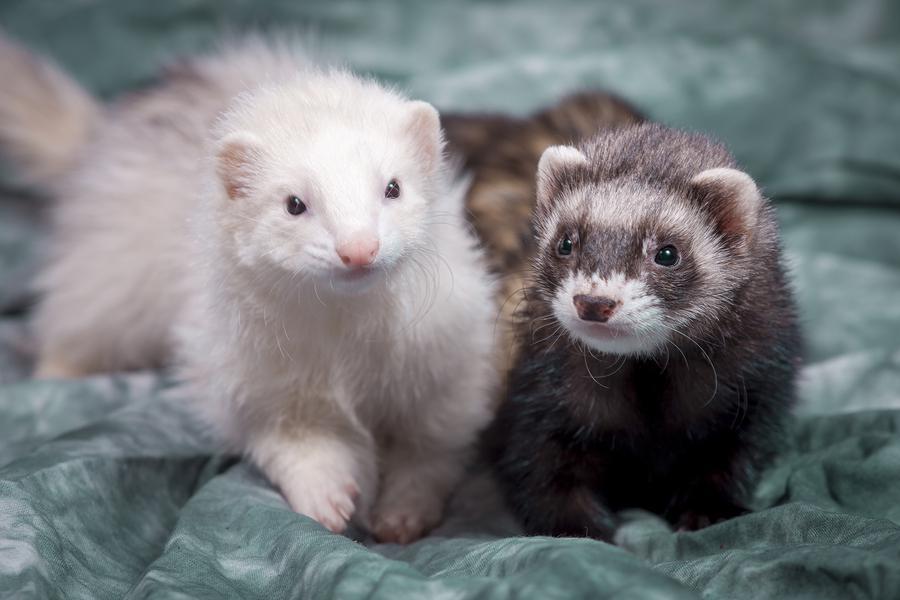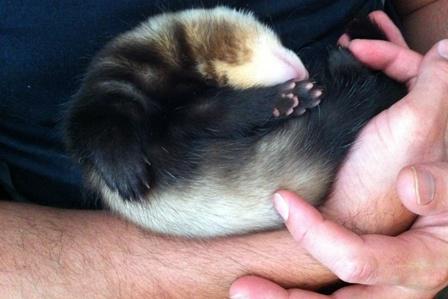The first image is the image on the left, the second image is the image on the right. Considering the images on both sides, is "The right image features a human hand holding a ferret." valid? Answer yes or no. Yes. 